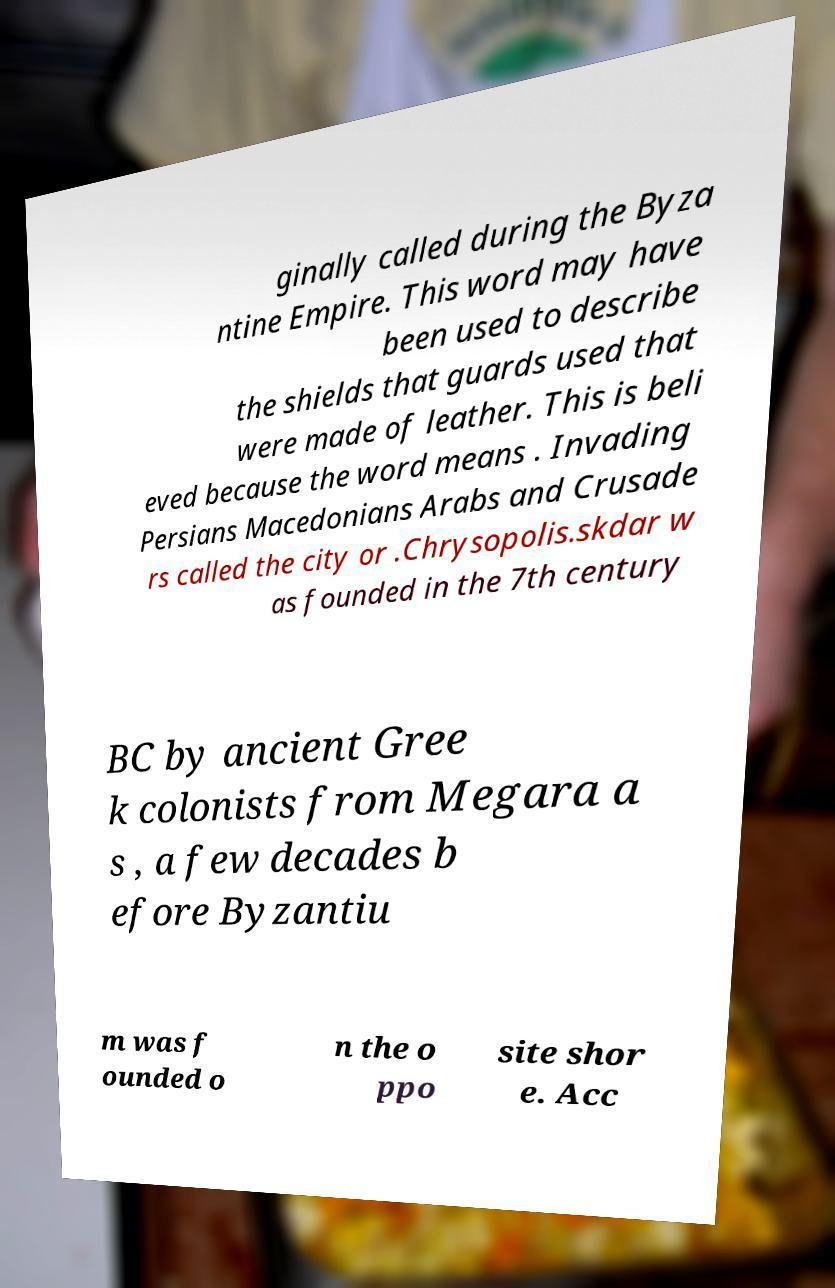There's text embedded in this image that I need extracted. Can you transcribe it verbatim? ginally called during the Byza ntine Empire. This word may have been used to describe the shields that guards used that were made of leather. This is beli eved because the word means . Invading Persians Macedonians Arabs and Crusade rs called the city or .Chrysopolis.skdar w as founded in the 7th century BC by ancient Gree k colonists from Megara a s , a few decades b efore Byzantiu m was f ounded o n the o ppo site shor e. Acc 